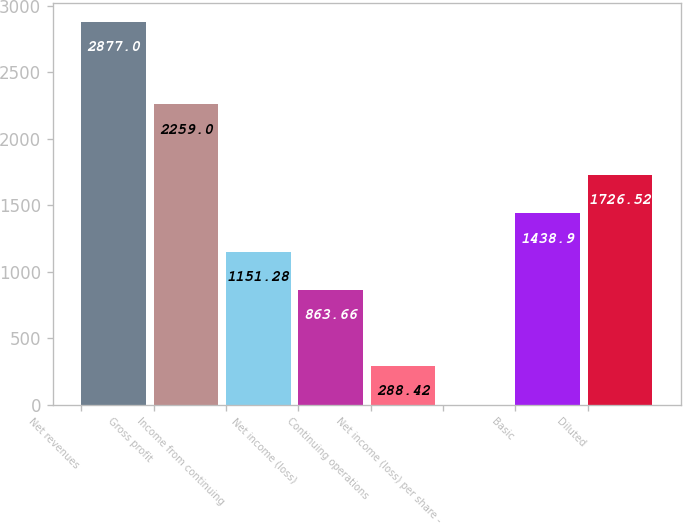Convert chart to OTSL. <chart><loc_0><loc_0><loc_500><loc_500><bar_chart><fcel>Net revenues<fcel>Gross profit<fcel>Income from continuing<fcel>Net income (loss)<fcel>Continuing operations<fcel>Net income (loss) per share -<fcel>Basic<fcel>Diluted<nl><fcel>2877<fcel>2259<fcel>1151.28<fcel>863.66<fcel>288.42<fcel>0.8<fcel>1438.9<fcel>1726.52<nl></chart> 